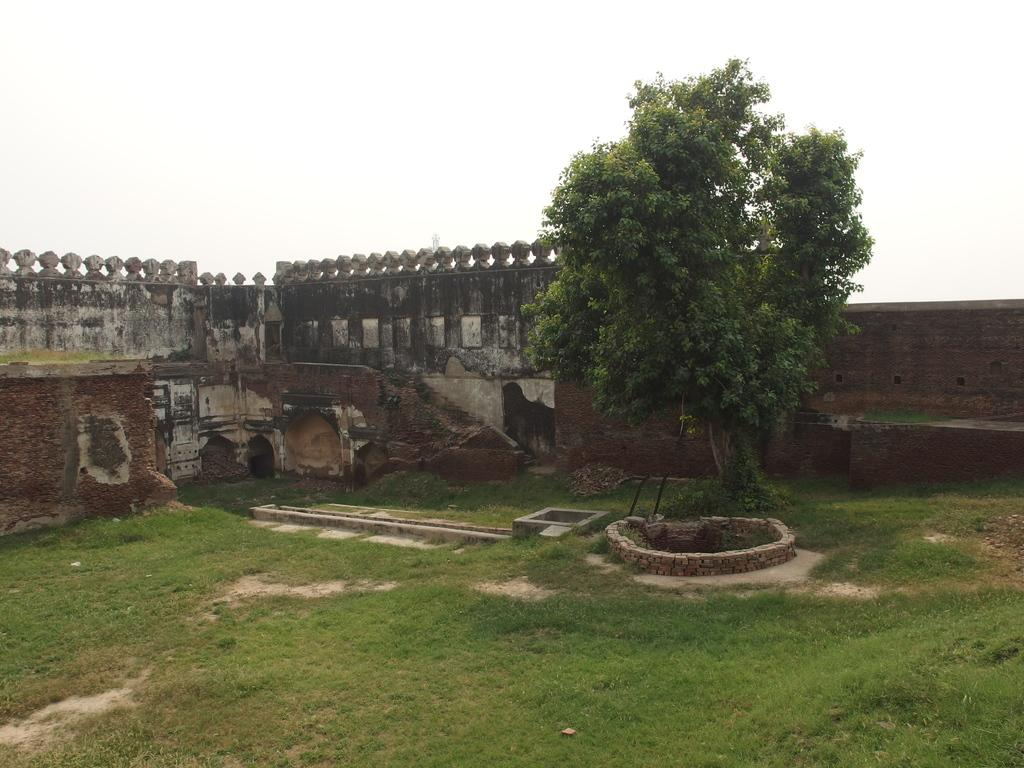What type of surface is visible in the image? There is grass on the surface in the image. What can be seen at the back side of the image? There is a tree and a wall at the back side of the image. What type of answer can be seen in the image? There is no answer present in the image; it features grass, a tree, and a wall. Is there a party happening in the image? There is no indication of a party in the image. 